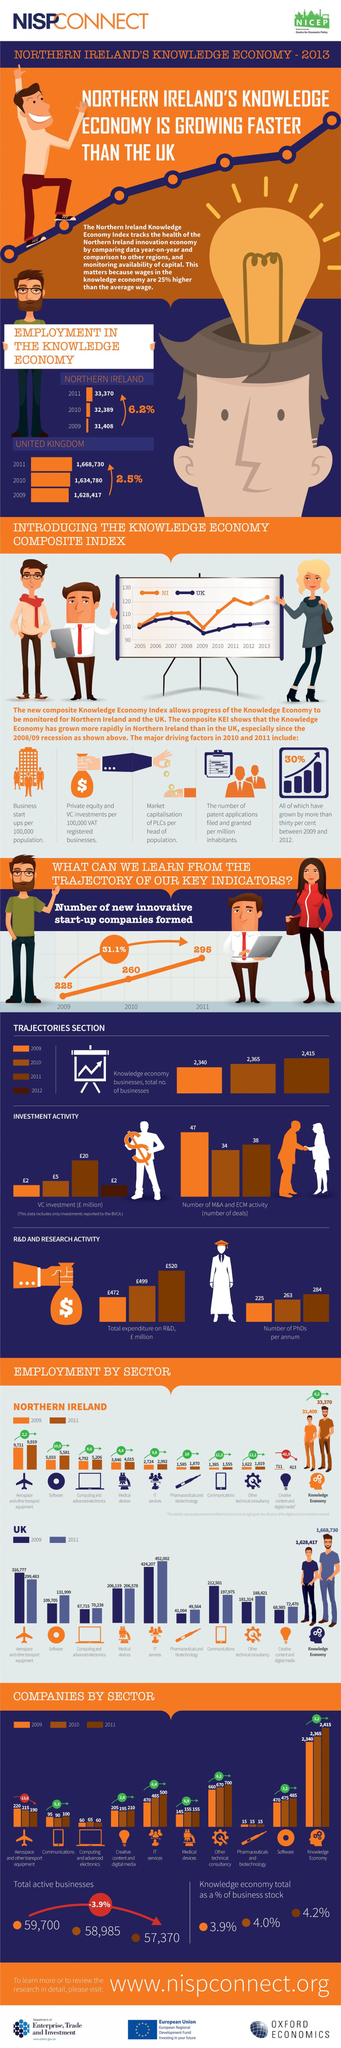What is the difference between the employment rate of the UK in the software sector in 2011 and 2009?
Answer the question with a short phrase. 22294 What is the difference between the total number of businesses in 2011 and 2009? 25 What is the difference between the employment rate of Northern Ireland in the software sector in 2011 and 2009? 548 What is the difference between the employment rate of Northern Ireland in the IT sector in 2011 and 2009? 268 